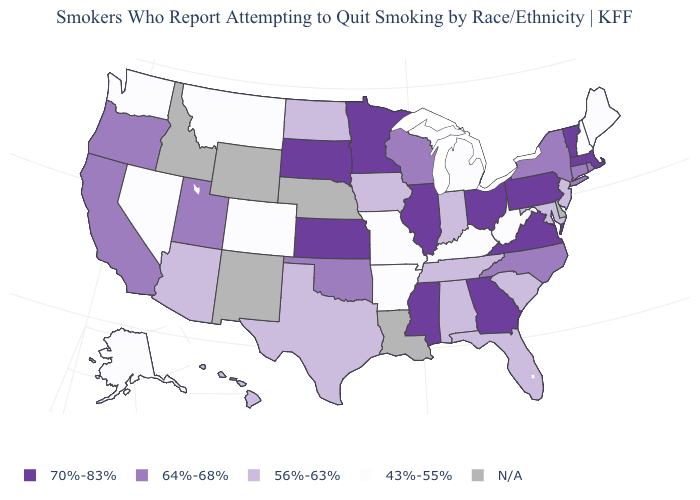What is the value of Oregon?
Be succinct. 64%-68%. What is the value of Alaska?
Keep it brief. 43%-55%. What is the value of Virginia?
Concise answer only. 70%-83%. How many symbols are there in the legend?
Write a very short answer. 5. What is the value of Hawaii?
Concise answer only. 56%-63%. Which states have the highest value in the USA?
Answer briefly. Georgia, Illinois, Kansas, Massachusetts, Minnesota, Mississippi, Ohio, Pennsylvania, South Dakota, Vermont, Virginia. Which states hav the highest value in the West?
Quick response, please. California, Oregon, Utah. Name the states that have a value in the range 56%-63%?
Be succinct. Alabama, Arizona, Florida, Hawaii, Indiana, Iowa, Maryland, New Jersey, North Dakota, South Carolina, Tennessee, Texas. Name the states that have a value in the range 64%-68%?
Give a very brief answer. California, Connecticut, New York, North Carolina, Oklahoma, Oregon, Rhode Island, Utah, Wisconsin. Which states hav the highest value in the West?
Concise answer only. California, Oregon, Utah. What is the value of Oregon?
Answer briefly. 64%-68%. What is the value of Michigan?
Concise answer only. 43%-55%. Name the states that have a value in the range N/A?
Keep it brief. Delaware, Idaho, Louisiana, Nebraska, New Mexico, Wyoming. 